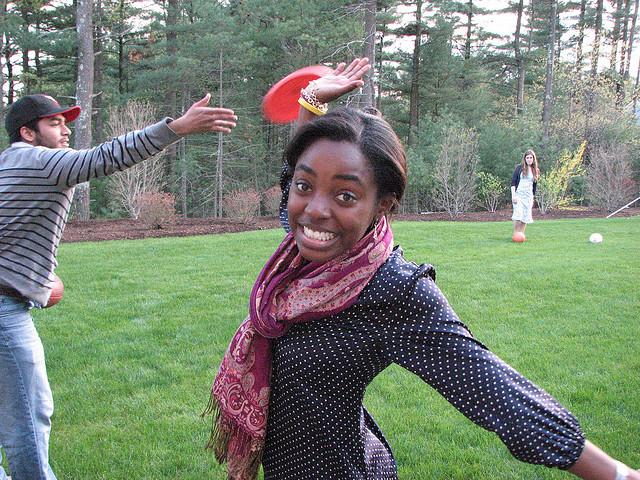Is the man clean cut?
Short answer required. No. What is the man throwing?
Keep it brief. Frisbee. What color is the Frisbee?
Answer briefly. Red. 